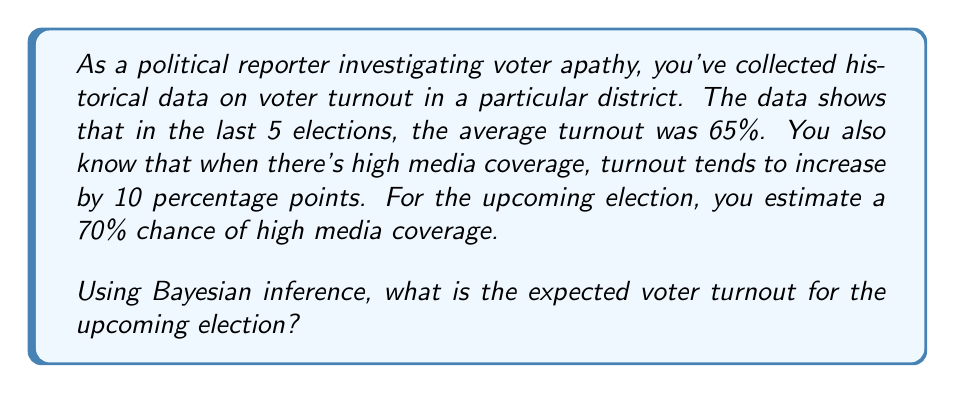Give your solution to this math problem. To solve this problem using Bayesian inference, we'll follow these steps:

1. Define our prior probability based on historical data.
2. Determine the likelihood of our new information.
3. Calculate the posterior probability using Bayes' theorem.

Let's break it down:

1. Prior probability:
   The average turnout in the last 5 elections was 65%. This is our prior probability.
   $P(\text{Turnout} = 65\%) = 0.65$

2. Likelihood:
   We know that high media coverage increases turnout by 10 percentage points.
   $P(\text{High Coverage} | \text{Turnout} = 75\%) = 0.7$
   $P(\text{Low Coverage} | \text{Turnout} = 65\%) = 0.3$

3. Posterior probability:
   We'll use Bayes' theorem to calculate the posterior probability:

   $$P(A|B) = \frac{P(B|A) \cdot P(A)}{P(B)}$$

   Where:
   A = Turnout is 75%
   B = High media coverage

   $$P(\text{Turnout} = 75\% | \text{High Coverage}) = \frac{P(\text{High Coverage} | \text{Turnout} = 75\%) \cdot P(\text{Turnout} = 75\%)}{P(\text{High Coverage})}$$

   We don't know $P(\text{Turnout} = 75\%)$ directly, but we can calculate it:
   $P(\text{Turnout} = 75\%) = 0.65 + (0.1 \cdot 0.7) = 0.72$

   Now we can calculate:
   $$P(\text{Turnout} = 75\% | \text{High Coverage}) = \frac{0.7 \cdot 0.72}{0.7} = 0.72$$

4. Expected voter turnout:
   To calculate the expected voter turnout, we use the weighted average:

   $E(\text{Turnout}) = 75\% \cdot P(\text{Turnout} = 75\% | \text{High Coverage}) + 65\% \cdot (1 - P(\text{Turnout} = 75\% | \text{High Coverage}))$
   
   $E(\text{Turnout}) = 0.75 \cdot 0.72 + 0.65 \cdot (1 - 0.72)$
   
   $E(\text{Turnout}) = 0.54 + 0.182 = 0.722$

Therefore, the expected voter turnout for the upcoming election is 72.2%.
Answer: 72.2% 